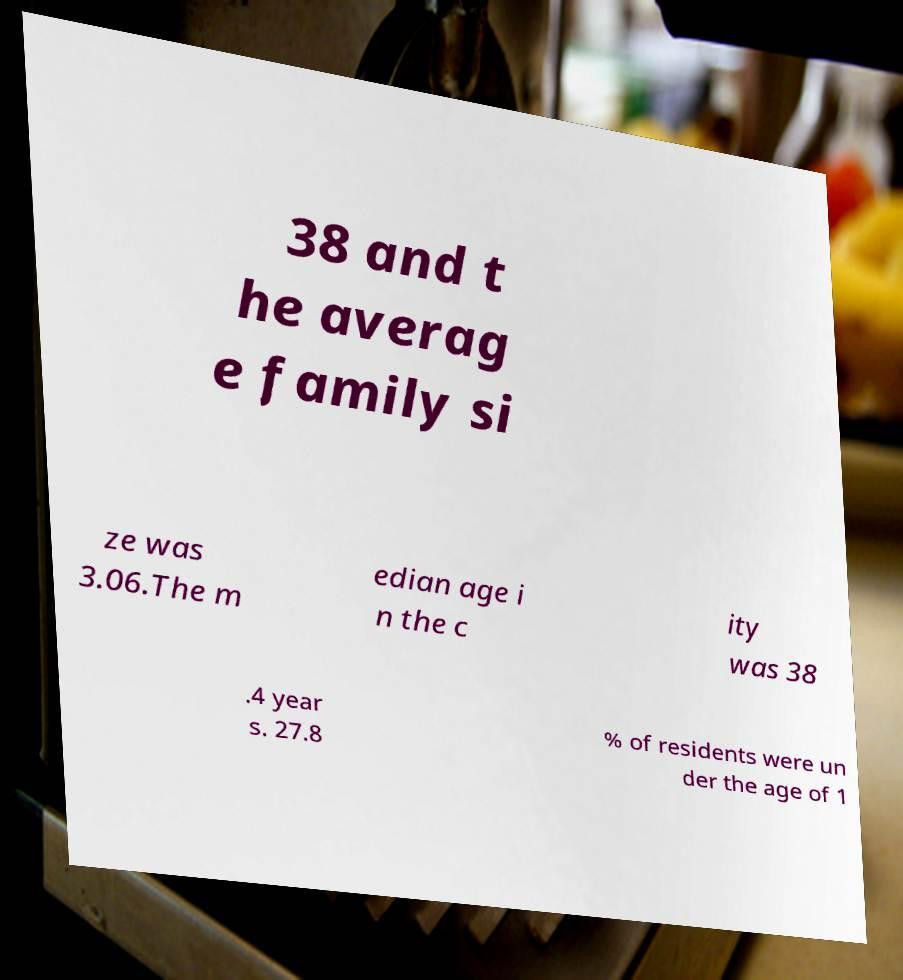Please identify and transcribe the text found in this image. 38 and t he averag e family si ze was 3.06.The m edian age i n the c ity was 38 .4 year s. 27.8 % of residents were un der the age of 1 